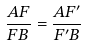<formula> <loc_0><loc_0><loc_500><loc_500>\frac { A F } { F B } = \frac { A F ^ { \prime } } { F ^ { \prime } B }</formula> 